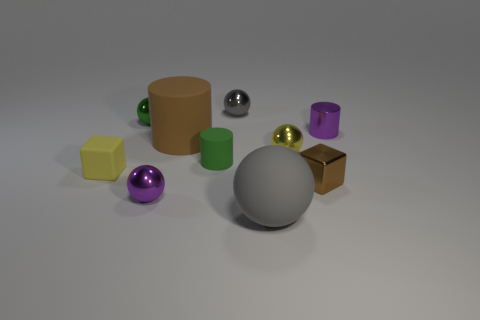Do the tiny metallic block and the large matte cylinder have the same color?
Make the answer very short. Yes. There is a purple thing that is the same shape as the tiny yellow shiny object; what is it made of?
Your answer should be very brief. Metal. What shape is the small metal object that is the same color as the matte block?
Keep it short and to the point. Sphere. Is the color of the object that is behind the green ball the same as the matte object to the right of the small rubber cylinder?
Ensure brevity in your answer.  Yes. Is there a small metal block that has the same color as the large cylinder?
Offer a terse response. Yes. Are there an equal number of brown cylinders behind the gray shiny sphere and green rubber things?
Provide a short and direct response. No. How many things are small purple objects in front of the matte block or small green cylinders?
Ensure brevity in your answer.  2. What is the shape of the metal object that is both behind the large brown cylinder and to the right of the gray metallic object?
Provide a succinct answer. Cylinder. What number of things are small balls that are to the left of the green matte thing or green rubber things in front of the yellow shiny ball?
Offer a very short reply. 3. How many other objects are the same size as the gray metallic sphere?
Offer a very short reply. 7. 